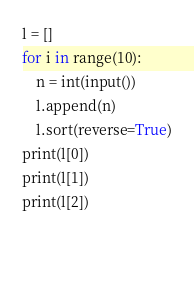Convert code to text. <code><loc_0><loc_0><loc_500><loc_500><_Python_>l = []
for i in range(10):
    n = int(input())
    l.append(n)
    l.sort(reverse=True)
print(l[0])
print(l[1])
print(l[2])

    
</code> 